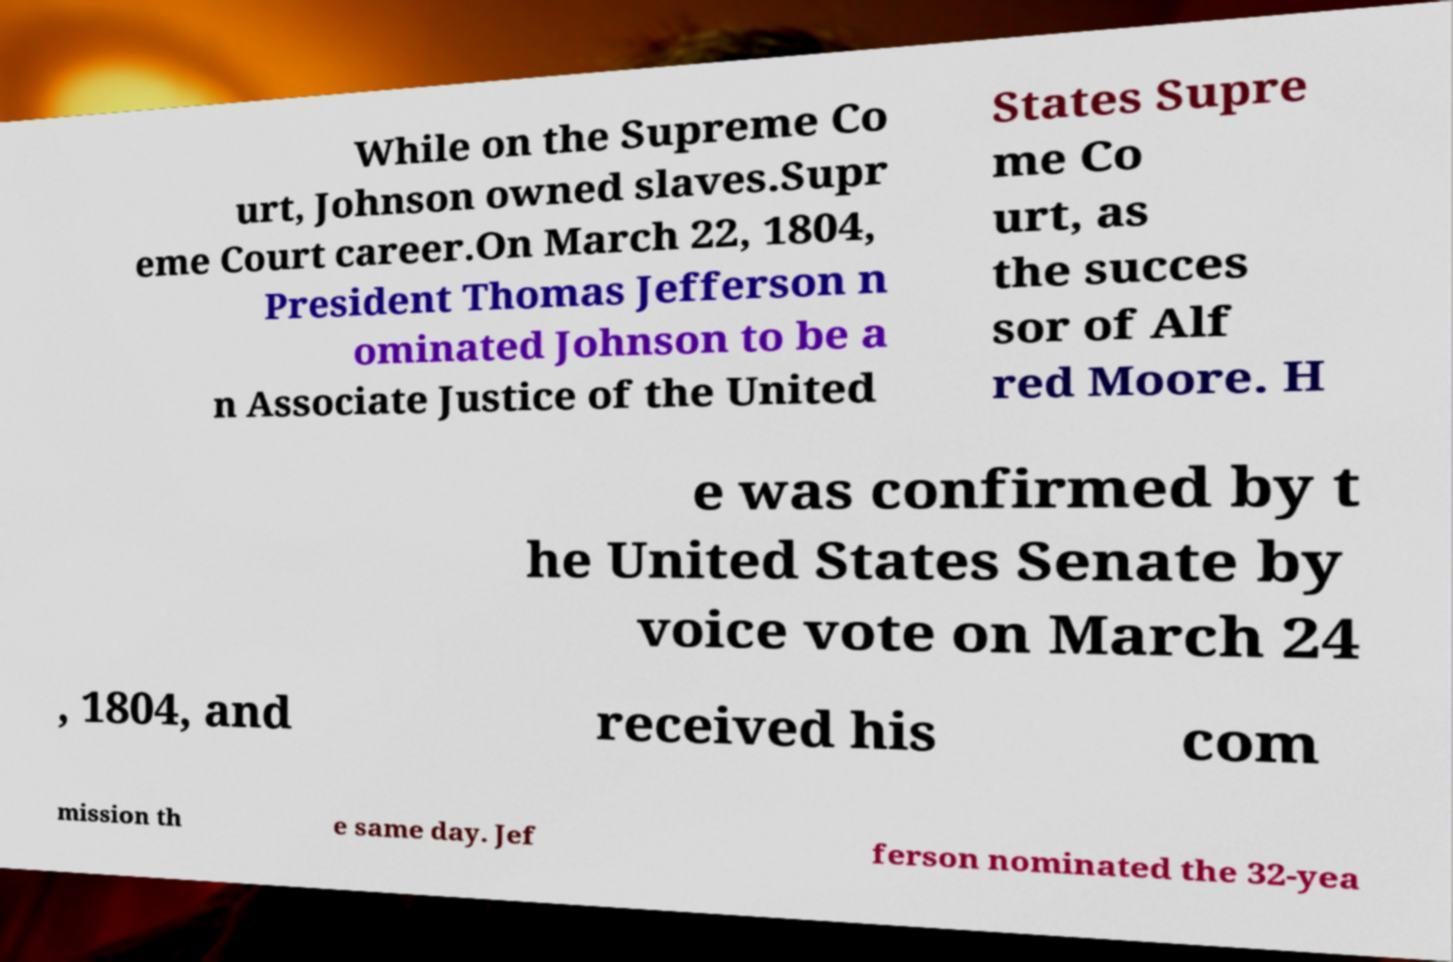Please identify and transcribe the text found in this image. While on the Supreme Co urt, Johnson owned slaves.Supr eme Court career.On March 22, 1804, President Thomas Jefferson n ominated Johnson to be a n Associate Justice of the United States Supre me Co urt, as the succes sor of Alf red Moore. H e was confirmed by t he United States Senate by voice vote on March 24 , 1804, and received his com mission th e same day. Jef ferson nominated the 32-yea 